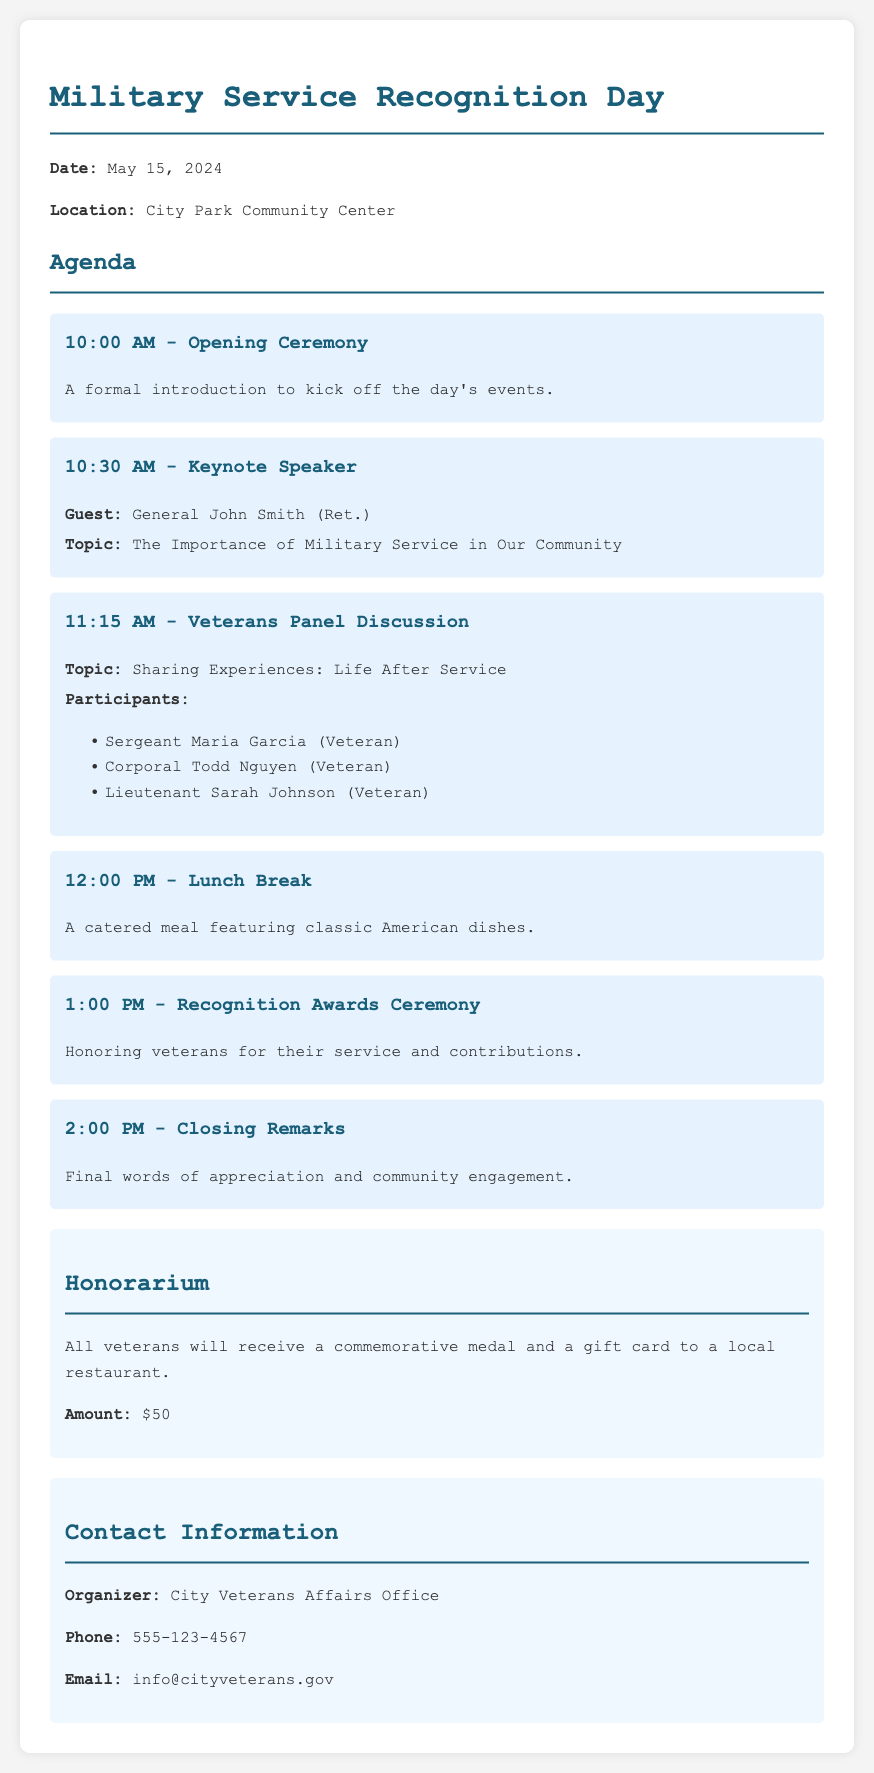What is the date of the event? The date of the event is specified in the document as May 15, 2024.
Answer: May 15, 2024 Where will the Military Service Recognition Day take place? The location of the event is mentioned as City Park Community Center.
Answer: City Park Community Center Who is the keynote speaker? The document lists General John Smith (Ret.) as the keynote speaker.
Answer: General John Smith (Ret.) What is the topic of the keynote speech? The document states that the topic is "The Importance of Military Service in Our Community."
Answer: The Importance of Military Service in Our Community What time does the lunch break start? The agenda indicates that the lunch break starts at 12:00 PM.
Answer: 12:00 PM How many panel participants are mentioned? The document lists three panel participants, which can be counted.
Answer: Three What will all veterans receive as part of the honorarium? The honorarium section states that all veterans will receive a commemorative medal and a gift card.
Answer: A commemorative medal and a gift card What is the amount of the gift card given to veterans? The document specifies the amount for the gift card is $50.
Answer: $50 Who can be contacted for more information about the event? The contact section names the City Veterans Affairs Office as the organizer for inquiries.
Answer: City Veterans Affairs Office 